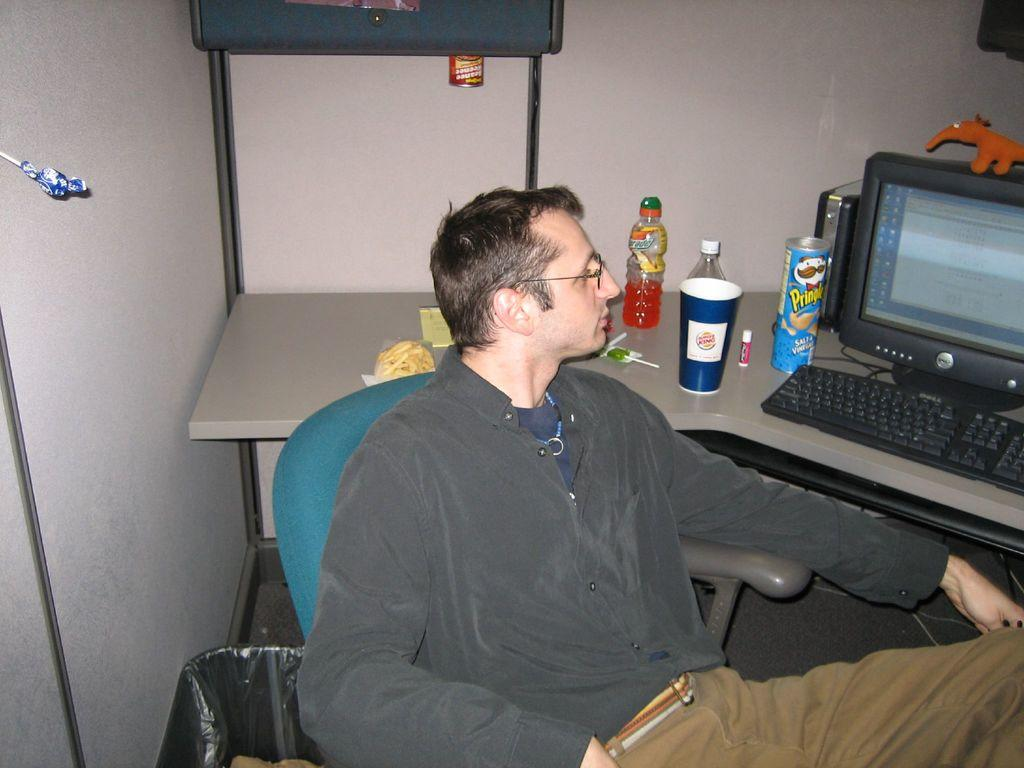<image>
Describe the image concisely. A man is sitting at a desk with a blue pringles container in front of him 